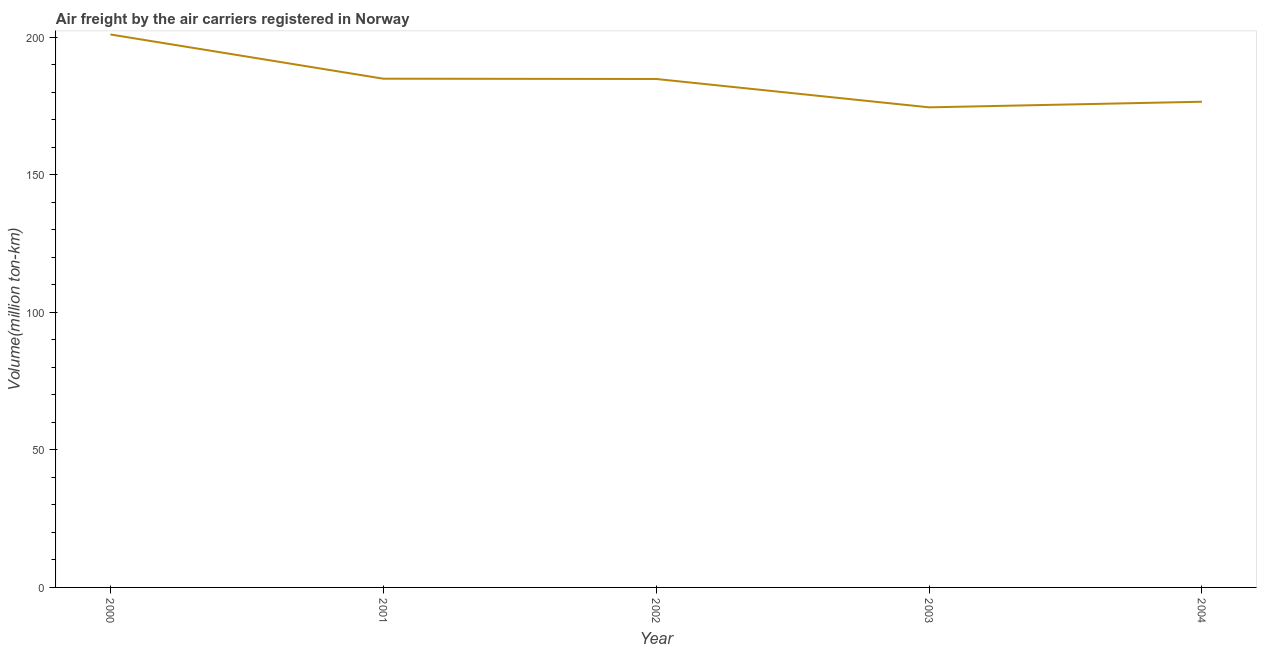What is the air freight in 2002?
Give a very brief answer. 184.86. Across all years, what is the maximum air freight?
Give a very brief answer. 201.04. Across all years, what is the minimum air freight?
Keep it short and to the point. 174.55. In which year was the air freight maximum?
Give a very brief answer. 2000. What is the sum of the air freight?
Provide a short and direct response. 922. What is the difference between the air freight in 2001 and 2004?
Your response must be concise. 8.38. What is the average air freight per year?
Give a very brief answer. 184.4. What is the median air freight?
Offer a very short reply. 184.86. Do a majority of the years between 2001 and 2003 (inclusive) have air freight greater than 30 million ton-km?
Offer a terse response. Yes. What is the ratio of the air freight in 2001 to that in 2004?
Offer a terse response. 1.05. What is the difference between the highest and the second highest air freight?
Provide a short and direct response. 16.08. Is the sum of the air freight in 2000 and 2004 greater than the maximum air freight across all years?
Your response must be concise. Yes. What is the difference between the highest and the lowest air freight?
Your answer should be compact. 26.49. Does the air freight monotonically increase over the years?
Ensure brevity in your answer.  No. How many lines are there?
Make the answer very short. 1. Are the values on the major ticks of Y-axis written in scientific E-notation?
Ensure brevity in your answer.  No. Does the graph contain any zero values?
Ensure brevity in your answer.  No. What is the title of the graph?
Your answer should be very brief. Air freight by the air carriers registered in Norway. What is the label or title of the Y-axis?
Your response must be concise. Volume(million ton-km). What is the Volume(million ton-km) of 2000?
Ensure brevity in your answer.  201.04. What is the Volume(million ton-km) of 2001?
Your answer should be compact. 184.96. What is the Volume(million ton-km) in 2002?
Ensure brevity in your answer.  184.86. What is the Volume(million ton-km) of 2003?
Offer a terse response. 174.55. What is the Volume(million ton-km) of 2004?
Make the answer very short. 176.59. What is the difference between the Volume(million ton-km) in 2000 and 2001?
Your answer should be compact. 16.08. What is the difference between the Volume(million ton-km) in 2000 and 2002?
Keep it short and to the point. 16.18. What is the difference between the Volume(million ton-km) in 2000 and 2003?
Your answer should be very brief. 26.49. What is the difference between the Volume(million ton-km) in 2000 and 2004?
Your answer should be compact. 24.46. What is the difference between the Volume(million ton-km) in 2001 and 2002?
Ensure brevity in your answer.  0.1. What is the difference between the Volume(million ton-km) in 2001 and 2003?
Ensure brevity in your answer.  10.41. What is the difference between the Volume(million ton-km) in 2001 and 2004?
Offer a very short reply. 8.38. What is the difference between the Volume(million ton-km) in 2002 and 2003?
Your answer should be very brief. 10.31. What is the difference between the Volume(million ton-km) in 2002 and 2004?
Provide a short and direct response. 8.27. What is the difference between the Volume(million ton-km) in 2003 and 2004?
Offer a terse response. -2.04. What is the ratio of the Volume(million ton-km) in 2000 to that in 2001?
Keep it short and to the point. 1.09. What is the ratio of the Volume(million ton-km) in 2000 to that in 2002?
Make the answer very short. 1.09. What is the ratio of the Volume(million ton-km) in 2000 to that in 2003?
Make the answer very short. 1.15. What is the ratio of the Volume(million ton-km) in 2000 to that in 2004?
Your answer should be compact. 1.14. What is the ratio of the Volume(million ton-km) in 2001 to that in 2002?
Your response must be concise. 1. What is the ratio of the Volume(million ton-km) in 2001 to that in 2003?
Provide a short and direct response. 1.06. What is the ratio of the Volume(million ton-km) in 2001 to that in 2004?
Ensure brevity in your answer.  1.05. What is the ratio of the Volume(million ton-km) in 2002 to that in 2003?
Ensure brevity in your answer.  1.06. What is the ratio of the Volume(million ton-km) in 2002 to that in 2004?
Offer a terse response. 1.05. 